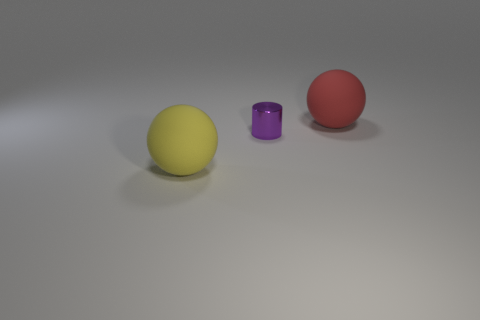What can you infer about the texture of the objects? The objects exhibit different textures: the spheres have a matte finish, diffusing light without glare, while the small cylinder has a metallic sheen that reflects light, indicating it has a smoother and likely reflective surface. 